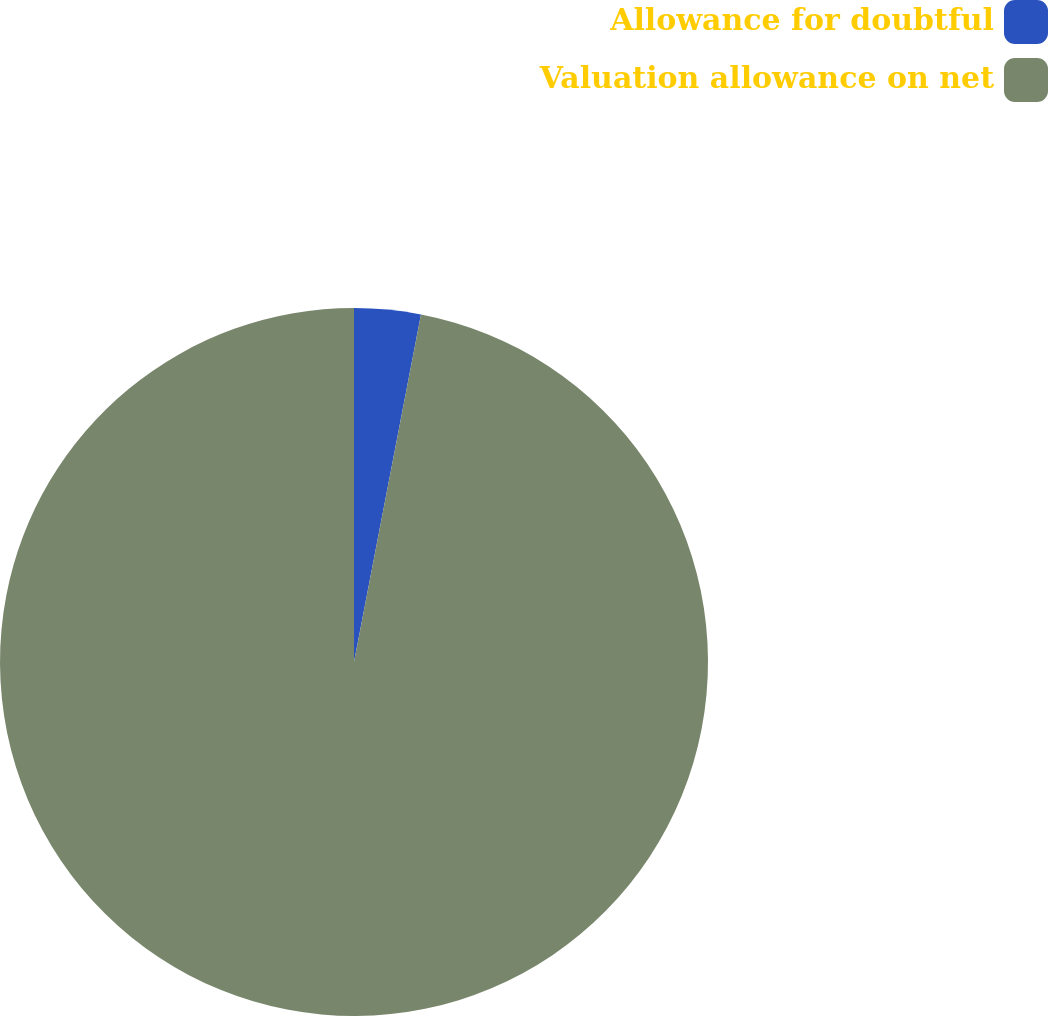<chart> <loc_0><loc_0><loc_500><loc_500><pie_chart><fcel>Allowance for doubtful<fcel>Valuation allowance on net<nl><fcel>3.03%<fcel>96.97%<nl></chart> 